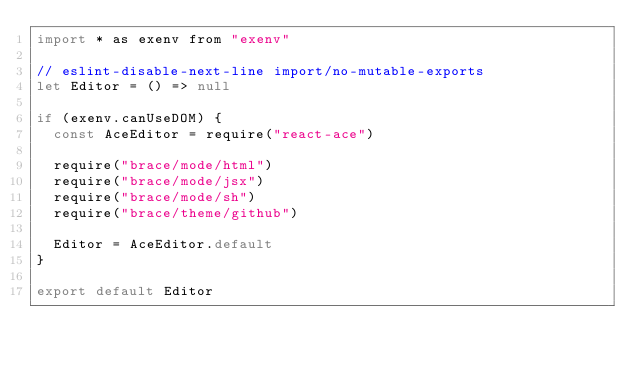<code> <loc_0><loc_0><loc_500><loc_500><_JavaScript_>import * as exenv from "exenv"

// eslint-disable-next-line import/no-mutable-exports
let Editor = () => null

if (exenv.canUseDOM) {
  const AceEditor = require("react-ace")

  require("brace/mode/html")
  require("brace/mode/jsx")
  require("brace/mode/sh")
  require("brace/theme/github")

  Editor = AceEditor.default
}

export default Editor
</code> 